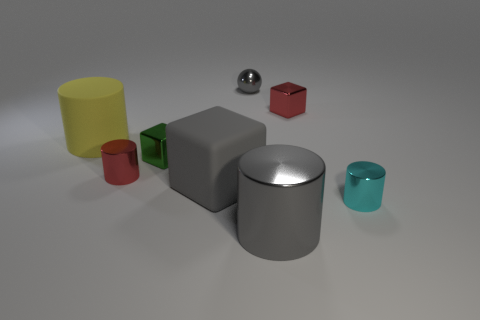Add 1 tiny green rubber balls. How many objects exist? 9 Subtract all small red metallic cylinders. How many cylinders are left? 3 Subtract 1 blocks. How many blocks are left? 2 Subtract all red cylinders. How many cylinders are left? 3 Subtract all cubes. How many objects are left? 5 Subtract all green cylinders. Subtract all purple spheres. How many cylinders are left? 4 Add 4 tiny green rubber cubes. How many tiny green rubber cubes exist? 4 Subtract 0 red balls. How many objects are left? 8 Subtract all big brown matte balls. Subtract all gray rubber cubes. How many objects are left? 7 Add 5 tiny things. How many tiny things are left? 10 